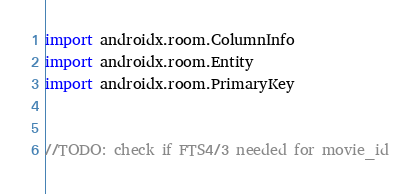Convert code to text. <code><loc_0><loc_0><loc_500><loc_500><_Kotlin_>import androidx.room.ColumnInfo
import androidx.room.Entity
import androidx.room.PrimaryKey


//TODO: check if FTS4/3 needed for movie_id
</code> 